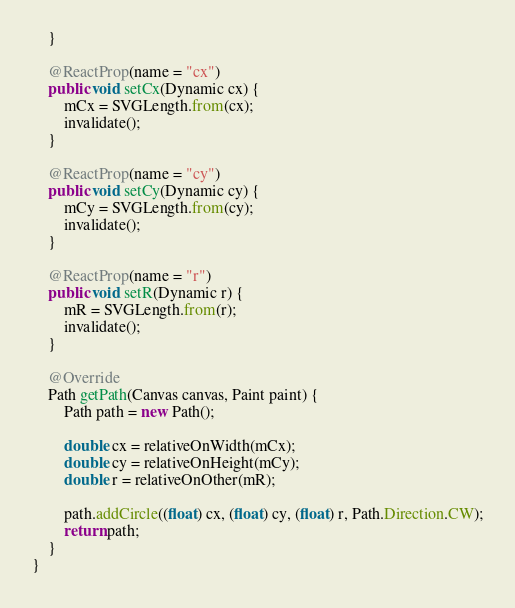Convert code to text. <code><loc_0><loc_0><loc_500><loc_500><_Java_>    }

    @ReactProp(name = "cx")
    public void setCx(Dynamic cx) {
        mCx = SVGLength.from(cx);
        invalidate();
    }

    @ReactProp(name = "cy")
    public void setCy(Dynamic cy) {
        mCy = SVGLength.from(cy);
        invalidate();
    }

    @ReactProp(name = "r")
    public void setR(Dynamic r) {
        mR = SVGLength.from(r);
        invalidate();
    }

    @Override
    Path getPath(Canvas canvas, Paint paint) {
        Path path = new Path();

        double cx = relativeOnWidth(mCx);
        double cy = relativeOnHeight(mCy);
        double r = relativeOnOther(mR);

        path.addCircle((float) cx, (float) cy, (float) r, Path.Direction.CW);
        return path;
    }
}
</code> 